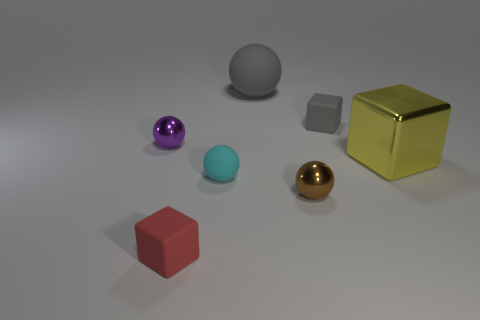Subtract all cyan balls. How many balls are left? 3 Subtract 3 balls. How many balls are left? 1 Add 2 purple balls. How many objects exist? 9 Subtract all yellow cubes. How many cubes are left? 2 Subtract all small cyan metal spheres. Subtract all big metallic blocks. How many objects are left? 6 Add 5 tiny cubes. How many tiny cubes are left? 7 Add 1 small purple balls. How many small purple balls exist? 2 Subtract 1 cyan spheres. How many objects are left? 6 Subtract all spheres. How many objects are left? 3 Subtract all purple blocks. Subtract all cyan cylinders. How many blocks are left? 3 